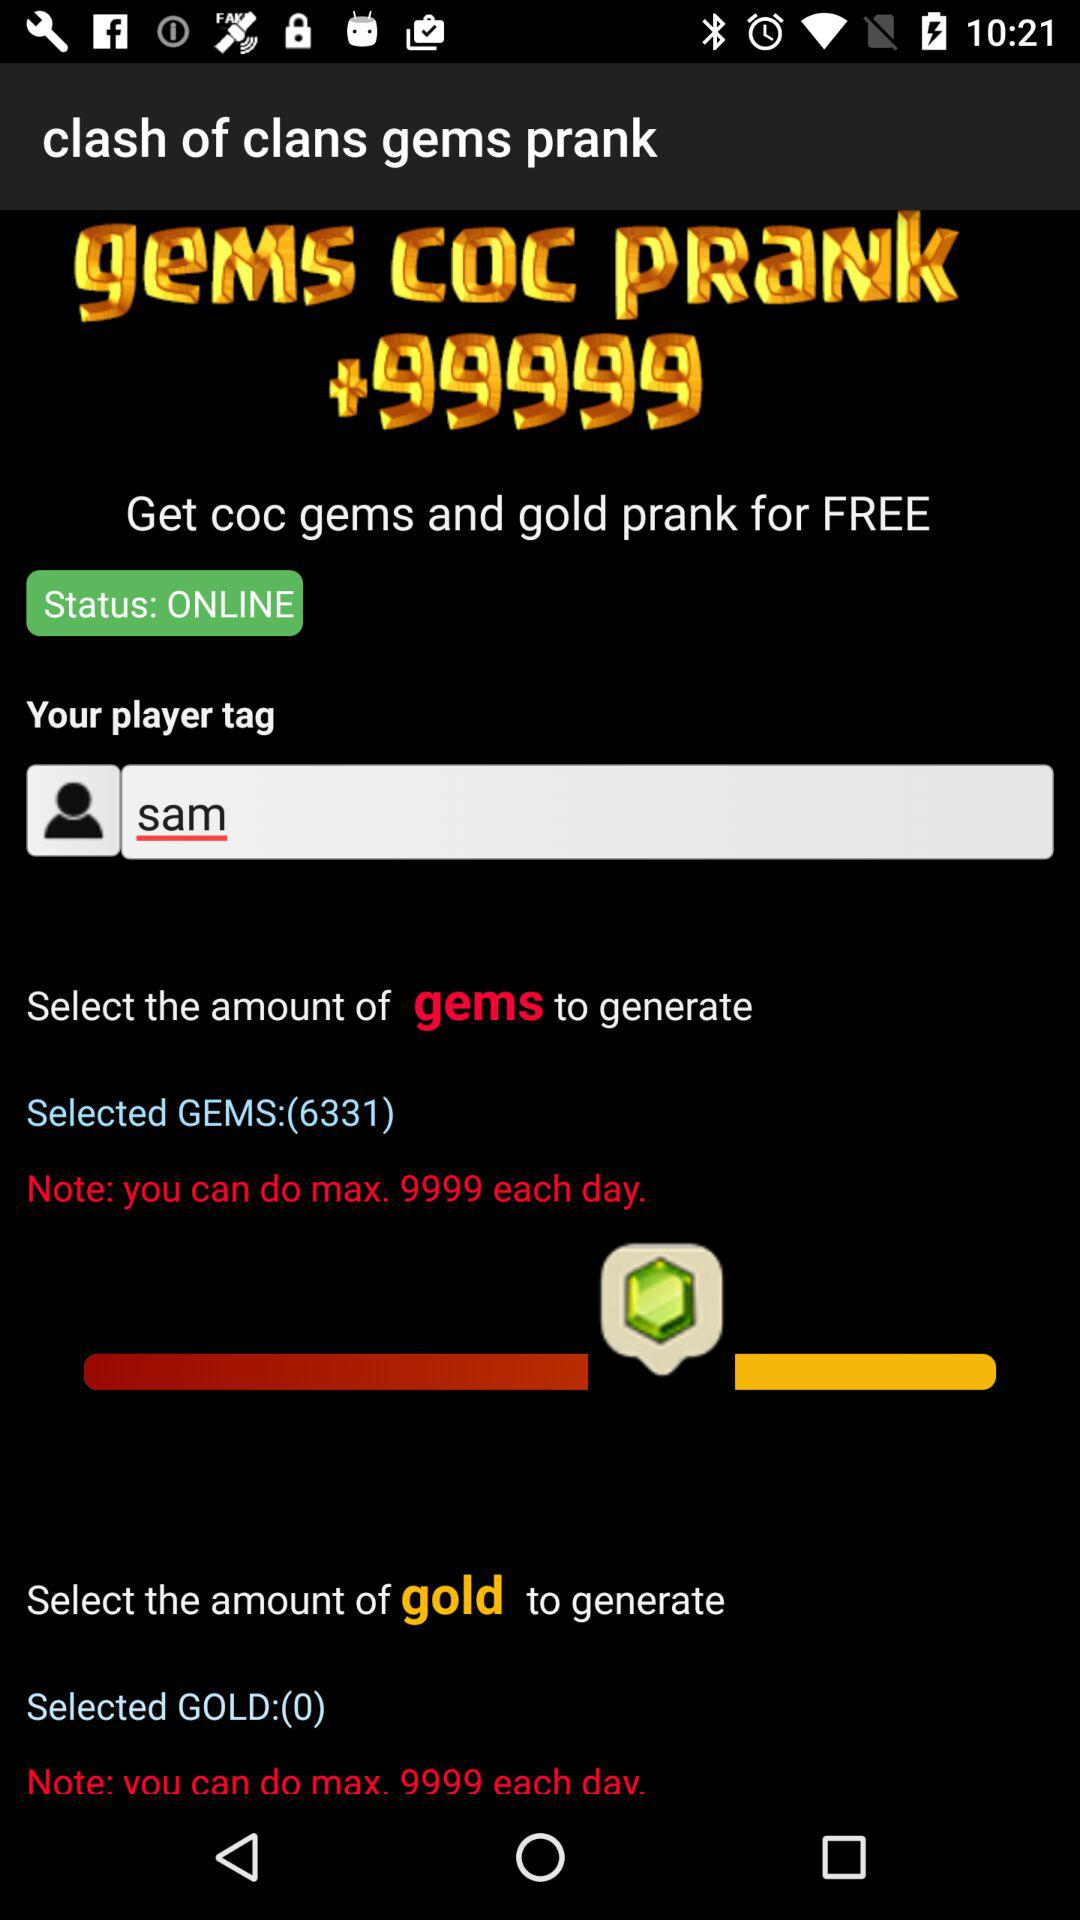How many gems can be generated each day? A maximum of 9999 gems can be generated each day. 